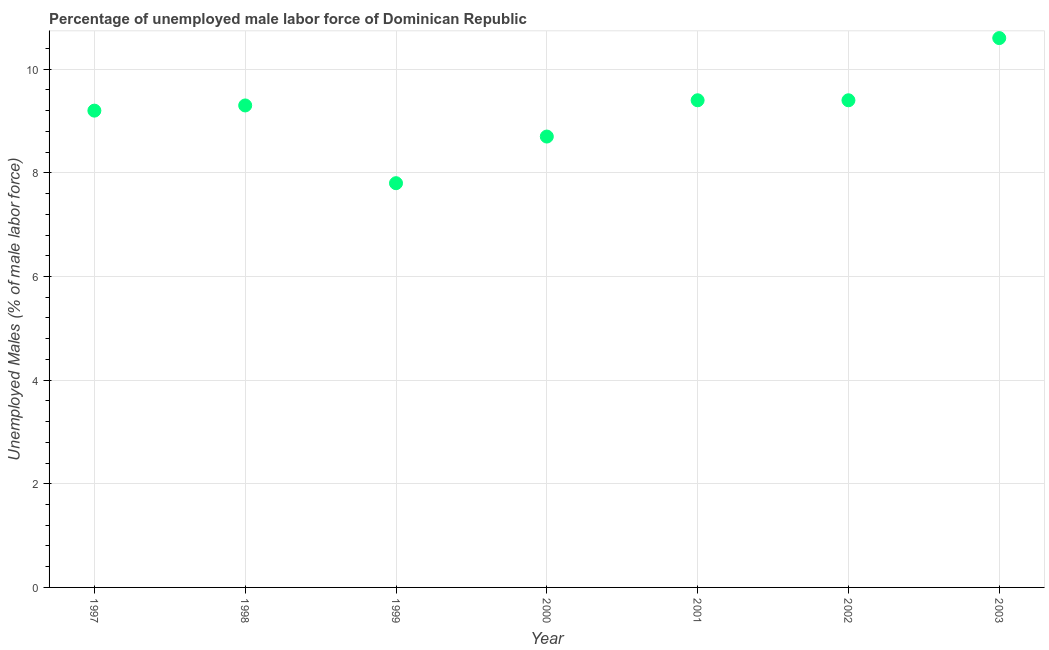What is the total unemployed male labour force in 1998?
Offer a very short reply. 9.3. Across all years, what is the maximum total unemployed male labour force?
Provide a short and direct response. 10.6. Across all years, what is the minimum total unemployed male labour force?
Offer a terse response. 7.8. What is the sum of the total unemployed male labour force?
Give a very brief answer. 64.4. What is the difference between the total unemployed male labour force in 1998 and 2000?
Offer a very short reply. 0.6. What is the average total unemployed male labour force per year?
Offer a terse response. 9.2. What is the median total unemployed male labour force?
Keep it short and to the point. 9.3. In how many years, is the total unemployed male labour force greater than 2.4 %?
Keep it short and to the point. 7. Do a majority of the years between 1999 and 1997 (inclusive) have total unemployed male labour force greater than 6.4 %?
Give a very brief answer. No. What is the ratio of the total unemployed male labour force in 2001 to that in 2002?
Your answer should be very brief. 1. What is the difference between the highest and the second highest total unemployed male labour force?
Provide a succinct answer. 1.2. What is the difference between the highest and the lowest total unemployed male labour force?
Your response must be concise. 2.8. Does the total unemployed male labour force monotonically increase over the years?
Offer a very short reply. No. How many years are there in the graph?
Provide a short and direct response. 7. Are the values on the major ticks of Y-axis written in scientific E-notation?
Provide a short and direct response. No. What is the title of the graph?
Keep it short and to the point. Percentage of unemployed male labor force of Dominican Republic. What is the label or title of the Y-axis?
Ensure brevity in your answer.  Unemployed Males (% of male labor force). What is the Unemployed Males (% of male labor force) in 1997?
Give a very brief answer. 9.2. What is the Unemployed Males (% of male labor force) in 1998?
Your answer should be very brief. 9.3. What is the Unemployed Males (% of male labor force) in 1999?
Your answer should be compact. 7.8. What is the Unemployed Males (% of male labor force) in 2000?
Give a very brief answer. 8.7. What is the Unemployed Males (% of male labor force) in 2001?
Your response must be concise. 9.4. What is the Unemployed Males (% of male labor force) in 2002?
Your response must be concise. 9.4. What is the Unemployed Males (% of male labor force) in 2003?
Offer a terse response. 10.6. What is the difference between the Unemployed Males (% of male labor force) in 1997 and 2000?
Provide a succinct answer. 0.5. What is the difference between the Unemployed Males (% of male labor force) in 1998 and 2000?
Your answer should be compact. 0.6. What is the difference between the Unemployed Males (% of male labor force) in 1998 and 2002?
Your answer should be very brief. -0.1. What is the difference between the Unemployed Males (% of male labor force) in 1998 and 2003?
Your answer should be compact. -1.3. What is the difference between the Unemployed Males (% of male labor force) in 1999 and 2001?
Your answer should be compact. -1.6. What is the difference between the Unemployed Males (% of male labor force) in 1999 and 2003?
Offer a very short reply. -2.8. What is the difference between the Unemployed Males (% of male labor force) in 2000 and 2001?
Offer a very short reply. -0.7. What is the difference between the Unemployed Males (% of male labor force) in 2000 and 2003?
Keep it short and to the point. -1.9. What is the difference between the Unemployed Males (% of male labor force) in 2001 and 2002?
Provide a short and direct response. 0. What is the difference between the Unemployed Males (% of male labor force) in 2001 and 2003?
Offer a terse response. -1.2. What is the ratio of the Unemployed Males (% of male labor force) in 1997 to that in 1999?
Provide a short and direct response. 1.18. What is the ratio of the Unemployed Males (% of male labor force) in 1997 to that in 2000?
Your answer should be very brief. 1.06. What is the ratio of the Unemployed Males (% of male labor force) in 1997 to that in 2001?
Provide a succinct answer. 0.98. What is the ratio of the Unemployed Males (% of male labor force) in 1997 to that in 2003?
Your answer should be compact. 0.87. What is the ratio of the Unemployed Males (% of male labor force) in 1998 to that in 1999?
Your answer should be very brief. 1.19. What is the ratio of the Unemployed Males (% of male labor force) in 1998 to that in 2000?
Give a very brief answer. 1.07. What is the ratio of the Unemployed Males (% of male labor force) in 1998 to that in 2001?
Your response must be concise. 0.99. What is the ratio of the Unemployed Males (% of male labor force) in 1998 to that in 2002?
Offer a terse response. 0.99. What is the ratio of the Unemployed Males (% of male labor force) in 1998 to that in 2003?
Offer a very short reply. 0.88. What is the ratio of the Unemployed Males (% of male labor force) in 1999 to that in 2000?
Keep it short and to the point. 0.9. What is the ratio of the Unemployed Males (% of male labor force) in 1999 to that in 2001?
Give a very brief answer. 0.83. What is the ratio of the Unemployed Males (% of male labor force) in 1999 to that in 2002?
Offer a terse response. 0.83. What is the ratio of the Unemployed Males (% of male labor force) in 1999 to that in 2003?
Provide a succinct answer. 0.74. What is the ratio of the Unemployed Males (% of male labor force) in 2000 to that in 2001?
Your answer should be compact. 0.93. What is the ratio of the Unemployed Males (% of male labor force) in 2000 to that in 2002?
Make the answer very short. 0.93. What is the ratio of the Unemployed Males (% of male labor force) in 2000 to that in 2003?
Ensure brevity in your answer.  0.82. What is the ratio of the Unemployed Males (% of male labor force) in 2001 to that in 2003?
Your answer should be very brief. 0.89. What is the ratio of the Unemployed Males (% of male labor force) in 2002 to that in 2003?
Give a very brief answer. 0.89. 